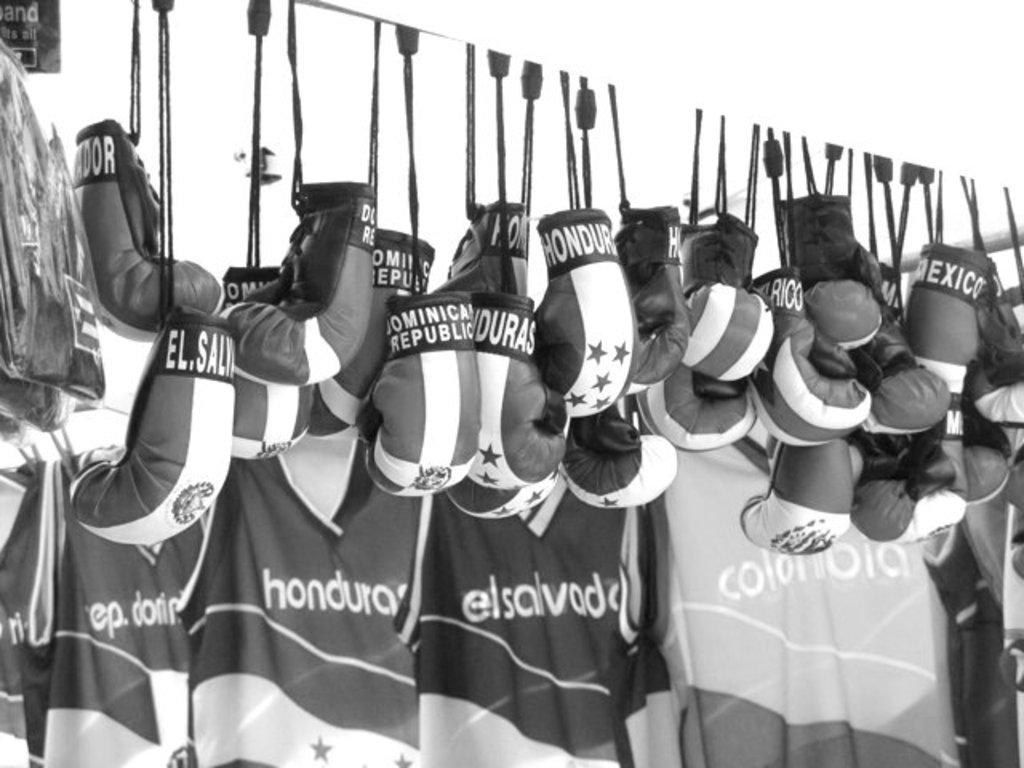<image>
Summarize the visual content of the image. A black and white picture of various spanish boxing gloves and jerseys hang. 